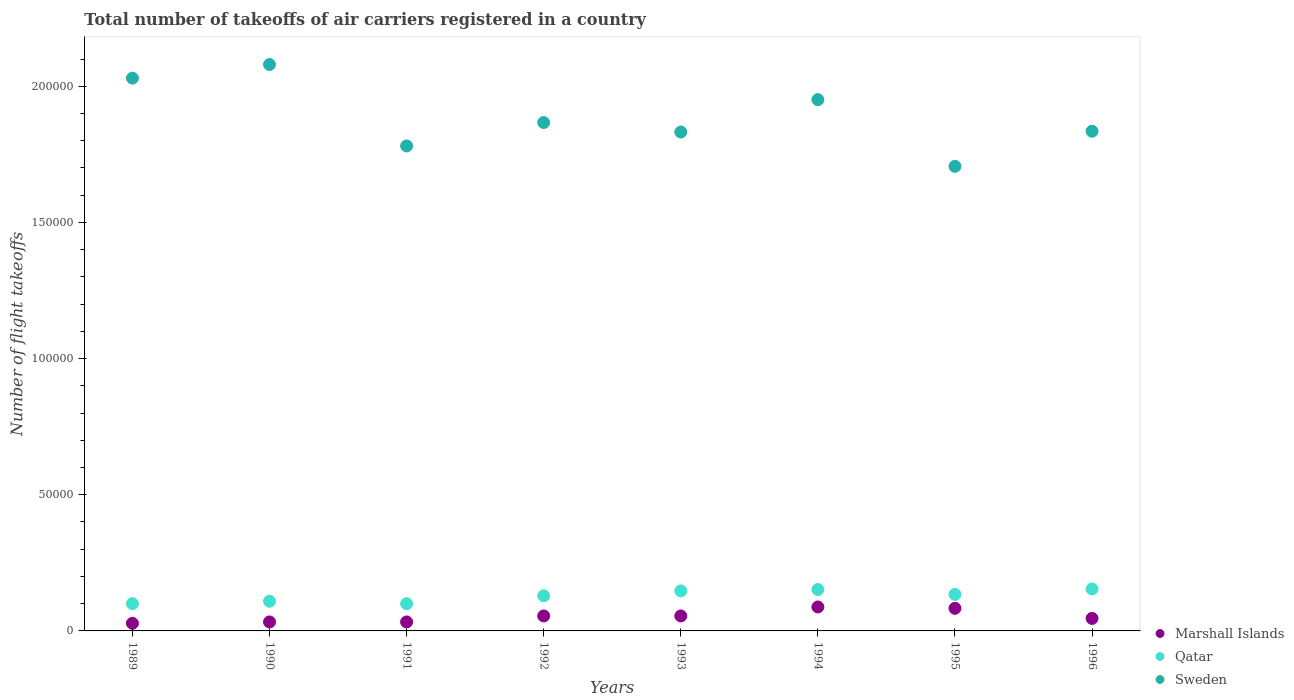Is the number of dotlines equal to the number of legend labels?
Your answer should be very brief. Yes. What is the total number of flight takeoffs in Qatar in 1996?
Offer a very short reply. 1.54e+04. Across all years, what is the maximum total number of flight takeoffs in Sweden?
Offer a terse response. 2.08e+05. Across all years, what is the minimum total number of flight takeoffs in Qatar?
Make the answer very short. 10000. In which year was the total number of flight takeoffs in Sweden minimum?
Offer a terse response. 1995. What is the total total number of flight takeoffs in Sweden in the graph?
Your answer should be very brief. 1.51e+06. What is the difference between the total number of flight takeoffs in Qatar in 1991 and that in 1995?
Make the answer very short. -3400. What is the difference between the total number of flight takeoffs in Sweden in 1992 and the total number of flight takeoffs in Marshall Islands in 1989?
Make the answer very short. 1.84e+05. What is the average total number of flight takeoffs in Sweden per year?
Give a very brief answer. 1.89e+05. In the year 1990, what is the difference between the total number of flight takeoffs in Qatar and total number of flight takeoffs in Sweden?
Keep it short and to the point. -1.97e+05. In how many years, is the total number of flight takeoffs in Qatar greater than 160000?
Give a very brief answer. 0. What is the ratio of the total number of flight takeoffs in Sweden in 1993 to that in 1995?
Keep it short and to the point. 1.07. Is the difference between the total number of flight takeoffs in Qatar in 1991 and 1995 greater than the difference between the total number of flight takeoffs in Sweden in 1991 and 1995?
Give a very brief answer. No. What is the difference between the highest and the second highest total number of flight takeoffs in Marshall Islands?
Make the answer very short. 500. What is the difference between the highest and the lowest total number of flight takeoffs in Marshall Islands?
Offer a very short reply. 6000. In how many years, is the total number of flight takeoffs in Sweden greater than the average total number of flight takeoffs in Sweden taken over all years?
Offer a terse response. 3. Is the total number of flight takeoffs in Sweden strictly greater than the total number of flight takeoffs in Qatar over the years?
Give a very brief answer. Yes. Is the total number of flight takeoffs in Sweden strictly less than the total number of flight takeoffs in Qatar over the years?
Offer a terse response. No. How many dotlines are there?
Make the answer very short. 3. What is the difference between two consecutive major ticks on the Y-axis?
Offer a terse response. 5.00e+04. Are the values on the major ticks of Y-axis written in scientific E-notation?
Your response must be concise. No. Does the graph contain any zero values?
Provide a succinct answer. No. Does the graph contain grids?
Ensure brevity in your answer.  No. What is the title of the graph?
Your answer should be compact. Total number of takeoffs of air carriers registered in a country. Does "Maldives" appear as one of the legend labels in the graph?
Keep it short and to the point. No. What is the label or title of the Y-axis?
Offer a terse response. Number of flight takeoffs. What is the Number of flight takeoffs of Marshall Islands in 1989?
Your response must be concise. 2800. What is the Number of flight takeoffs of Qatar in 1989?
Ensure brevity in your answer.  10000. What is the Number of flight takeoffs in Sweden in 1989?
Ensure brevity in your answer.  2.03e+05. What is the Number of flight takeoffs in Marshall Islands in 1990?
Offer a terse response. 3300. What is the Number of flight takeoffs in Qatar in 1990?
Your answer should be compact. 1.09e+04. What is the Number of flight takeoffs of Sweden in 1990?
Provide a short and direct response. 2.08e+05. What is the Number of flight takeoffs of Marshall Islands in 1991?
Offer a terse response. 3300. What is the Number of flight takeoffs of Qatar in 1991?
Your response must be concise. 10000. What is the Number of flight takeoffs of Sweden in 1991?
Give a very brief answer. 1.78e+05. What is the Number of flight takeoffs of Marshall Islands in 1992?
Provide a short and direct response. 5500. What is the Number of flight takeoffs of Qatar in 1992?
Your answer should be compact. 1.29e+04. What is the Number of flight takeoffs in Sweden in 1992?
Offer a very short reply. 1.87e+05. What is the Number of flight takeoffs of Marshall Islands in 1993?
Offer a very short reply. 5500. What is the Number of flight takeoffs in Qatar in 1993?
Provide a succinct answer. 1.47e+04. What is the Number of flight takeoffs of Sweden in 1993?
Offer a terse response. 1.83e+05. What is the Number of flight takeoffs in Marshall Islands in 1994?
Your response must be concise. 8800. What is the Number of flight takeoffs of Qatar in 1994?
Your response must be concise. 1.52e+04. What is the Number of flight takeoffs of Sweden in 1994?
Give a very brief answer. 1.95e+05. What is the Number of flight takeoffs of Marshall Islands in 1995?
Offer a very short reply. 8300. What is the Number of flight takeoffs of Qatar in 1995?
Offer a very short reply. 1.34e+04. What is the Number of flight takeoffs in Sweden in 1995?
Provide a succinct answer. 1.71e+05. What is the Number of flight takeoffs in Marshall Islands in 1996?
Ensure brevity in your answer.  4600. What is the Number of flight takeoffs of Qatar in 1996?
Provide a succinct answer. 1.54e+04. What is the Number of flight takeoffs of Sweden in 1996?
Give a very brief answer. 1.84e+05. Across all years, what is the maximum Number of flight takeoffs in Marshall Islands?
Ensure brevity in your answer.  8800. Across all years, what is the maximum Number of flight takeoffs in Qatar?
Keep it short and to the point. 1.54e+04. Across all years, what is the maximum Number of flight takeoffs in Sweden?
Keep it short and to the point. 2.08e+05. Across all years, what is the minimum Number of flight takeoffs in Marshall Islands?
Make the answer very short. 2800. Across all years, what is the minimum Number of flight takeoffs of Qatar?
Ensure brevity in your answer.  10000. Across all years, what is the minimum Number of flight takeoffs in Sweden?
Your response must be concise. 1.71e+05. What is the total Number of flight takeoffs of Marshall Islands in the graph?
Make the answer very short. 4.21e+04. What is the total Number of flight takeoffs of Qatar in the graph?
Your response must be concise. 1.02e+05. What is the total Number of flight takeoffs of Sweden in the graph?
Provide a short and direct response. 1.51e+06. What is the difference between the Number of flight takeoffs of Marshall Islands in 1989 and that in 1990?
Make the answer very short. -500. What is the difference between the Number of flight takeoffs of Qatar in 1989 and that in 1990?
Your answer should be compact. -900. What is the difference between the Number of flight takeoffs of Sweden in 1989 and that in 1990?
Keep it short and to the point. -5000. What is the difference between the Number of flight takeoffs in Marshall Islands in 1989 and that in 1991?
Provide a short and direct response. -500. What is the difference between the Number of flight takeoffs of Sweden in 1989 and that in 1991?
Your answer should be very brief. 2.49e+04. What is the difference between the Number of flight takeoffs in Marshall Islands in 1989 and that in 1992?
Provide a short and direct response. -2700. What is the difference between the Number of flight takeoffs of Qatar in 1989 and that in 1992?
Your answer should be compact. -2900. What is the difference between the Number of flight takeoffs in Sweden in 1989 and that in 1992?
Your answer should be very brief. 1.63e+04. What is the difference between the Number of flight takeoffs of Marshall Islands in 1989 and that in 1993?
Your answer should be very brief. -2700. What is the difference between the Number of flight takeoffs in Qatar in 1989 and that in 1993?
Your answer should be very brief. -4700. What is the difference between the Number of flight takeoffs in Sweden in 1989 and that in 1993?
Give a very brief answer. 1.98e+04. What is the difference between the Number of flight takeoffs in Marshall Islands in 1989 and that in 1994?
Give a very brief answer. -6000. What is the difference between the Number of flight takeoffs of Qatar in 1989 and that in 1994?
Make the answer very short. -5200. What is the difference between the Number of flight takeoffs in Sweden in 1989 and that in 1994?
Give a very brief answer. 7900. What is the difference between the Number of flight takeoffs of Marshall Islands in 1989 and that in 1995?
Provide a succinct answer. -5500. What is the difference between the Number of flight takeoffs of Qatar in 1989 and that in 1995?
Your response must be concise. -3400. What is the difference between the Number of flight takeoffs in Sweden in 1989 and that in 1995?
Provide a short and direct response. 3.24e+04. What is the difference between the Number of flight takeoffs in Marshall Islands in 1989 and that in 1996?
Your answer should be very brief. -1800. What is the difference between the Number of flight takeoffs in Qatar in 1989 and that in 1996?
Provide a succinct answer. -5400. What is the difference between the Number of flight takeoffs in Sweden in 1989 and that in 1996?
Ensure brevity in your answer.  1.95e+04. What is the difference between the Number of flight takeoffs of Marshall Islands in 1990 and that in 1991?
Your response must be concise. 0. What is the difference between the Number of flight takeoffs in Qatar in 1990 and that in 1991?
Keep it short and to the point. 900. What is the difference between the Number of flight takeoffs in Sweden in 1990 and that in 1991?
Keep it short and to the point. 2.99e+04. What is the difference between the Number of flight takeoffs in Marshall Islands in 1990 and that in 1992?
Provide a succinct answer. -2200. What is the difference between the Number of flight takeoffs in Qatar in 1990 and that in 1992?
Offer a terse response. -2000. What is the difference between the Number of flight takeoffs of Sweden in 1990 and that in 1992?
Make the answer very short. 2.13e+04. What is the difference between the Number of flight takeoffs of Marshall Islands in 1990 and that in 1993?
Provide a short and direct response. -2200. What is the difference between the Number of flight takeoffs of Qatar in 1990 and that in 1993?
Provide a short and direct response. -3800. What is the difference between the Number of flight takeoffs in Sweden in 1990 and that in 1993?
Ensure brevity in your answer.  2.48e+04. What is the difference between the Number of flight takeoffs in Marshall Islands in 1990 and that in 1994?
Your answer should be very brief. -5500. What is the difference between the Number of flight takeoffs in Qatar in 1990 and that in 1994?
Provide a short and direct response. -4300. What is the difference between the Number of flight takeoffs in Sweden in 1990 and that in 1994?
Offer a very short reply. 1.29e+04. What is the difference between the Number of flight takeoffs of Marshall Islands in 1990 and that in 1995?
Your answer should be compact. -5000. What is the difference between the Number of flight takeoffs of Qatar in 1990 and that in 1995?
Give a very brief answer. -2500. What is the difference between the Number of flight takeoffs of Sweden in 1990 and that in 1995?
Your answer should be very brief. 3.74e+04. What is the difference between the Number of flight takeoffs of Marshall Islands in 1990 and that in 1996?
Your response must be concise. -1300. What is the difference between the Number of flight takeoffs of Qatar in 1990 and that in 1996?
Offer a very short reply. -4500. What is the difference between the Number of flight takeoffs of Sweden in 1990 and that in 1996?
Make the answer very short. 2.45e+04. What is the difference between the Number of flight takeoffs of Marshall Islands in 1991 and that in 1992?
Keep it short and to the point. -2200. What is the difference between the Number of flight takeoffs of Qatar in 1991 and that in 1992?
Provide a succinct answer. -2900. What is the difference between the Number of flight takeoffs in Sweden in 1991 and that in 1992?
Ensure brevity in your answer.  -8600. What is the difference between the Number of flight takeoffs in Marshall Islands in 1991 and that in 1993?
Give a very brief answer. -2200. What is the difference between the Number of flight takeoffs in Qatar in 1991 and that in 1993?
Offer a terse response. -4700. What is the difference between the Number of flight takeoffs of Sweden in 1991 and that in 1993?
Ensure brevity in your answer.  -5100. What is the difference between the Number of flight takeoffs in Marshall Islands in 1991 and that in 1994?
Keep it short and to the point. -5500. What is the difference between the Number of flight takeoffs of Qatar in 1991 and that in 1994?
Keep it short and to the point. -5200. What is the difference between the Number of flight takeoffs of Sweden in 1991 and that in 1994?
Your response must be concise. -1.70e+04. What is the difference between the Number of flight takeoffs in Marshall Islands in 1991 and that in 1995?
Offer a terse response. -5000. What is the difference between the Number of flight takeoffs in Qatar in 1991 and that in 1995?
Keep it short and to the point. -3400. What is the difference between the Number of flight takeoffs in Sweden in 1991 and that in 1995?
Provide a short and direct response. 7500. What is the difference between the Number of flight takeoffs of Marshall Islands in 1991 and that in 1996?
Make the answer very short. -1300. What is the difference between the Number of flight takeoffs of Qatar in 1991 and that in 1996?
Provide a short and direct response. -5400. What is the difference between the Number of flight takeoffs of Sweden in 1991 and that in 1996?
Ensure brevity in your answer.  -5400. What is the difference between the Number of flight takeoffs of Qatar in 1992 and that in 1993?
Keep it short and to the point. -1800. What is the difference between the Number of flight takeoffs of Sweden in 1992 and that in 1993?
Provide a short and direct response. 3500. What is the difference between the Number of flight takeoffs in Marshall Islands in 1992 and that in 1994?
Provide a succinct answer. -3300. What is the difference between the Number of flight takeoffs in Qatar in 1992 and that in 1994?
Offer a terse response. -2300. What is the difference between the Number of flight takeoffs of Sweden in 1992 and that in 1994?
Keep it short and to the point. -8400. What is the difference between the Number of flight takeoffs in Marshall Islands in 1992 and that in 1995?
Your answer should be compact. -2800. What is the difference between the Number of flight takeoffs in Qatar in 1992 and that in 1995?
Make the answer very short. -500. What is the difference between the Number of flight takeoffs of Sweden in 1992 and that in 1995?
Your answer should be very brief. 1.61e+04. What is the difference between the Number of flight takeoffs in Marshall Islands in 1992 and that in 1996?
Offer a terse response. 900. What is the difference between the Number of flight takeoffs in Qatar in 1992 and that in 1996?
Provide a succinct answer. -2500. What is the difference between the Number of flight takeoffs of Sweden in 1992 and that in 1996?
Your answer should be compact. 3200. What is the difference between the Number of flight takeoffs of Marshall Islands in 1993 and that in 1994?
Keep it short and to the point. -3300. What is the difference between the Number of flight takeoffs in Qatar in 1993 and that in 1994?
Provide a succinct answer. -500. What is the difference between the Number of flight takeoffs of Sweden in 1993 and that in 1994?
Make the answer very short. -1.19e+04. What is the difference between the Number of flight takeoffs of Marshall Islands in 1993 and that in 1995?
Offer a terse response. -2800. What is the difference between the Number of flight takeoffs of Qatar in 1993 and that in 1995?
Your answer should be compact. 1300. What is the difference between the Number of flight takeoffs of Sweden in 1993 and that in 1995?
Give a very brief answer. 1.26e+04. What is the difference between the Number of flight takeoffs of Marshall Islands in 1993 and that in 1996?
Your answer should be compact. 900. What is the difference between the Number of flight takeoffs in Qatar in 1993 and that in 1996?
Your answer should be compact. -700. What is the difference between the Number of flight takeoffs in Sweden in 1993 and that in 1996?
Your response must be concise. -300. What is the difference between the Number of flight takeoffs in Marshall Islands in 1994 and that in 1995?
Your answer should be compact. 500. What is the difference between the Number of flight takeoffs of Qatar in 1994 and that in 1995?
Give a very brief answer. 1800. What is the difference between the Number of flight takeoffs in Sweden in 1994 and that in 1995?
Your answer should be very brief. 2.45e+04. What is the difference between the Number of flight takeoffs in Marshall Islands in 1994 and that in 1996?
Make the answer very short. 4200. What is the difference between the Number of flight takeoffs of Qatar in 1994 and that in 1996?
Provide a succinct answer. -200. What is the difference between the Number of flight takeoffs in Sweden in 1994 and that in 1996?
Provide a short and direct response. 1.16e+04. What is the difference between the Number of flight takeoffs of Marshall Islands in 1995 and that in 1996?
Offer a terse response. 3700. What is the difference between the Number of flight takeoffs in Qatar in 1995 and that in 1996?
Offer a terse response. -2000. What is the difference between the Number of flight takeoffs of Sweden in 1995 and that in 1996?
Your response must be concise. -1.29e+04. What is the difference between the Number of flight takeoffs in Marshall Islands in 1989 and the Number of flight takeoffs in Qatar in 1990?
Give a very brief answer. -8100. What is the difference between the Number of flight takeoffs of Marshall Islands in 1989 and the Number of flight takeoffs of Sweden in 1990?
Keep it short and to the point. -2.05e+05. What is the difference between the Number of flight takeoffs in Qatar in 1989 and the Number of flight takeoffs in Sweden in 1990?
Provide a short and direct response. -1.98e+05. What is the difference between the Number of flight takeoffs in Marshall Islands in 1989 and the Number of flight takeoffs in Qatar in 1991?
Ensure brevity in your answer.  -7200. What is the difference between the Number of flight takeoffs in Marshall Islands in 1989 and the Number of flight takeoffs in Sweden in 1991?
Ensure brevity in your answer.  -1.75e+05. What is the difference between the Number of flight takeoffs of Qatar in 1989 and the Number of flight takeoffs of Sweden in 1991?
Provide a succinct answer. -1.68e+05. What is the difference between the Number of flight takeoffs of Marshall Islands in 1989 and the Number of flight takeoffs of Qatar in 1992?
Your response must be concise. -1.01e+04. What is the difference between the Number of flight takeoffs in Marshall Islands in 1989 and the Number of flight takeoffs in Sweden in 1992?
Offer a terse response. -1.84e+05. What is the difference between the Number of flight takeoffs in Qatar in 1989 and the Number of flight takeoffs in Sweden in 1992?
Your answer should be very brief. -1.77e+05. What is the difference between the Number of flight takeoffs in Marshall Islands in 1989 and the Number of flight takeoffs in Qatar in 1993?
Provide a succinct answer. -1.19e+04. What is the difference between the Number of flight takeoffs in Marshall Islands in 1989 and the Number of flight takeoffs in Sweden in 1993?
Provide a short and direct response. -1.80e+05. What is the difference between the Number of flight takeoffs of Qatar in 1989 and the Number of flight takeoffs of Sweden in 1993?
Your response must be concise. -1.73e+05. What is the difference between the Number of flight takeoffs of Marshall Islands in 1989 and the Number of flight takeoffs of Qatar in 1994?
Your answer should be compact. -1.24e+04. What is the difference between the Number of flight takeoffs of Marshall Islands in 1989 and the Number of flight takeoffs of Sweden in 1994?
Offer a terse response. -1.92e+05. What is the difference between the Number of flight takeoffs in Qatar in 1989 and the Number of flight takeoffs in Sweden in 1994?
Offer a terse response. -1.85e+05. What is the difference between the Number of flight takeoffs in Marshall Islands in 1989 and the Number of flight takeoffs in Qatar in 1995?
Provide a short and direct response. -1.06e+04. What is the difference between the Number of flight takeoffs in Marshall Islands in 1989 and the Number of flight takeoffs in Sweden in 1995?
Ensure brevity in your answer.  -1.68e+05. What is the difference between the Number of flight takeoffs in Qatar in 1989 and the Number of flight takeoffs in Sweden in 1995?
Offer a very short reply. -1.61e+05. What is the difference between the Number of flight takeoffs of Marshall Islands in 1989 and the Number of flight takeoffs of Qatar in 1996?
Make the answer very short. -1.26e+04. What is the difference between the Number of flight takeoffs of Marshall Islands in 1989 and the Number of flight takeoffs of Sweden in 1996?
Your answer should be very brief. -1.81e+05. What is the difference between the Number of flight takeoffs in Qatar in 1989 and the Number of flight takeoffs in Sweden in 1996?
Provide a short and direct response. -1.74e+05. What is the difference between the Number of flight takeoffs in Marshall Islands in 1990 and the Number of flight takeoffs in Qatar in 1991?
Provide a succinct answer. -6700. What is the difference between the Number of flight takeoffs in Marshall Islands in 1990 and the Number of flight takeoffs in Sweden in 1991?
Your answer should be very brief. -1.75e+05. What is the difference between the Number of flight takeoffs of Qatar in 1990 and the Number of flight takeoffs of Sweden in 1991?
Offer a terse response. -1.67e+05. What is the difference between the Number of flight takeoffs of Marshall Islands in 1990 and the Number of flight takeoffs of Qatar in 1992?
Keep it short and to the point. -9600. What is the difference between the Number of flight takeoffs of Marshall Islands in 1990 and the Number of flight takeoffs of Sweden in 1992?
Offer a very short reply. -1.83e+05. What is the difference between the Number of flight takeoffs in Qatar in 1990 and the Number of flight takeoffs in Sweden in 1992?
Offer a very short reply. -1.76e+05. What is the difference between the Number of flight takeoffs of Marshall Islands in 1990 and the Number of flight takeoffs of Qatar in 1993?
Provide a short and direct response. -1.14e+04. What is the difference between the Number of flight takeoffs of Marshall Islands in 1990 and the Number of flight takeoffs of Sweden in 1993?
Make the answer very short. -1.80e+05. What is the difference between the Number of flight takeoffs of Qatar in 1990 and the Number of flight takeoffs of Sweden in 1993?
Provide a succinct answer. -1.72e+05. What is the difference between the Number of flight takeoffs of Marshall Islands in 1990 and the Number of flight takeoffs of Qatar in 1994?
Your answer should be compact. -1.19e+04. What is the difference between the Number of flight takeoffs in Marshall Islands in 1990 and the Number of flight takeoffs in Sweden in 1994?
Provide a succinct answer. -1.92e+05. What is the difference between the Number of flight takeoffs of Qatar in 1990 and the Number of flight takeoffs of Sweden in 1994?
Give a very brief answer. -1.84e+05. What is the difference between the Number of flight takeoffs of Marshall Islands in 1990 and the Number of flight takeoffs of Qatar in 1995?
Your answer should be compact. -1.01e+04. What is the difference between the Number of flight takeoffs in Marshall Islands in 1990 and the Number of flight takeoffs in Sweden in 1995?
Ensure brevity in your answer.  -1.67e+05. What is the difference between the Number of flight takeoffs in Qatar in 1990 and the Number of flight takeoffs in Sweden in 1995?
Keep it short and to the point. -1.60e+05. What is the difference between the Number of flight takeoffs in Marshall Islands in 1990 and the Number of flight takeoffs in Qatar in 1996?
Provide a succinct answer. -1.21e+04. What is the difference between the Number of flight takeoffs in Marshall Islands in 1990 and the Number of flight takeoffs in Sweden in 1996?
Offer a terse response. -1.80e+05. What is the difference between the Number of flight takeoffs of Qatar in 1990 and the Number of flight takeoffs of Sweden in 1996?
Give a very brief answer. -1.73e+05. What is the difference between the Number of flight takeoffs in Marshall Islands in 1991 and the Number of flight takeoffs in Qatar in 1992?
Provide a short and direct response. -9600. What is the difference between the Number of flight takeoffs of Marshall Islands in 1991 and the Number of flight takeoffs of Sweden in 1992?
Offer a terse response. -1.83e+05. What is the difference between the Number of flight takeoffs of Qatar in 1991 and the Number of flight takeoffs of Sweden in 1992?
Your response must be concise. -1.77e+05. What is the difference between the Number of flight takeoffs in Marshall Islands in 1991 and the Number of flight takeoffs in Qatar in 1993?
Your response must be concise. -1.14e+04. What is the difference between the Number of flight takeoffs of Marshall Islands in 1991 and the Number of flight takeoffs of Sweden in 1993?
Give a very brief answer. -1.80e+05. What is the difference between the Number of flight takeoffs in Qatar in 1991 and the Number of flight takeoffs in Sweden in 1993?
Keep it short and to the point. -1.73e+05. What is the difference between the Number of flight takeoffs of Marshall Islands in 1991 and the Number of flight takeoffs of Qatar in 1994?
Give a very brief answer. -1.19e+04. What is the difference between the Number of flight takeoffs of Marshall Islands in 1991 and the Number of flight takeoffs of Sweden in 1994?
Keep it short and to the point. -1.92e+05. What is the difference between the Number of flight takeoffs in Qatar in 1991 and the Number of flight takeoffs in Sweden in 1994?
Offer a very short reply. -1.85e+05. What is the difference between the Number of flight takeoffs in Marshall Islands in 1991 and the Number of flight takeoffs in Qatar in 1995?
Your answer should be very brief. -1.01e+04. What is the difference between the Number of flight takeoffs in Marshall Islands in 1991 and the Number of flight takeoffs in Sweden in 1995?
Give a very brief answer. -1.67e+05. What is the difference between the Number of flight takeoffs in Qatar in 1991 and the Number of flight takeoffs in Sweden in 1995?
Offer a very short reply. -1.61e+05. What is the difference between the Number of flight takeoffs in Marshall Islands in 1991 and the Number of flight takeoffs in Qatar in 1996?
Make the answer very short. -1.21e+04. What is the difference between the Number of flight takeoffs in Marshall Islands in 1991 and the Number of flight takeoffs in Sweden in 1996?
Offer a very short reply. -1.80e+05. What is the difference between the Number of flight takeoffs of Qatar in 1991 and the Number of flight takeoffs of Sweden in 1996?
Keep it short and to the point. -1.74e+05. What is the difference between the Number of flight takeoffs in Marshall Islands in 1992 and the Number of flight takeoffs in Qatar in 1993?
Ensure brevity in your answer.  -9200. What is the difference between the Number of flight takeoffs in Marshall Islands in 1992 and the Number of flight takeoffs in Sweden in 1993?
Provide a short and direct response. -1.78e+05. What is the difference between the Number of flight takeoffs in Qatar in 1992 and the Number of flight takeoffs in Sweden in 1993?
Give a very brief answer. -1.70e+05. What is the difference between the Number of flight takeoffs of Marshall Islands in 1992 and the Number of flight takeoffs of Qatar in 1994?
Provide a succinct answer. -9700. What is the difference between the Number of flight takeoffs of Marshall Islands in 1992 and the Number of flight takeoffs of Sweden in 1994?
Your response must be concise. -1.90e+05. What is the difference between the Number of flight takeoffs of Qatar in 1992 and the Number of flight takeoffs of Sweden in 1994?
Your answer should be very brief. -1.82e+05. What is the difference between the Number of flight takeoffs of Marshall Islands in 1992 and the Number of flight takeoffs of Qatar in 1995?
Ensure brevity in your answer.  -7900. What is the difference between the Number of flight takeoffs of Marshall Islands in 1992 and the Number of flight takeoffs of Sweden in 1995?
Offer a terse response. -1.65e+05. What is the difference between the Number of flight takeoffs of Qatar in 1992 and the Number of flight takeoffs of Sweden in 1995?
Make the answer very short. -1.58e+05. What is the difference between the Number of flight takeoffs in Marshall Islands in 1992 and the Number of flight takeoffs in Qatar in 1996?
Keep it short and to the point. -9900. What is the difference between the Number of flight takeoffs of Marshall Islands in 1992 and the Number of flight takeoffs of Sweden in 1996?
Keep it short and to the point. -1.78e+05. What is the difference between the Number of flight takeoffs in Qatar in 1992 and the Number of flight takeoffs in Sweden in 1996?
Give a very brief answer. -1.71e+05. What is the difference between the Number of flight takeoffs in Marshall Islands in 1993 and the Number of flight takeoffs in Qatar in 1994?
Give a very brief answer. -9700. What is the difference between the Number of flight takeoffs in Marshall Islands in 1993 and the Number of flight takeoffs in Sweden in 1994?
Your answer should be compact. -1.90e+05. What is the difference between the Number of flight takeoffs in Qatar in 1993 and the Number of flight takeoffs in Sweden in 1994?
Make the answer very short. -1.80e+05. What is the difference between the Number of flight takeoffs of Marshall Islands in 1993 and the Number of flight takeoffs of Qatar in 1995?
Provide a succinct answer. -7900. What is the difference between the Number of flight takeoffs in Marshall Islands in 1993 and the Number of flight takeoffs in Sweden in 1995?
Make the answer very short. -1.65e+05. What is the difference between the Number of flight takeoffs of Qatar in 1993 and the Number of flight takeoffs of Sweden in 1995?
Provide a short and direct response. -1.56e+05. What is the difference between the Number of flight takeoffs in Marshall Islands in 1993 and the Number of flight takeoffs in Qatar in 1996?
Provide a succinct answer. -9900. What is the difference between the Number of flight takeoffs of Marshall Islands in 1993 and the Number of flight takeoffs of Sweden in 1996?
Provide a short and direct response. -1.78e+05. What is the difference between the Number of flight takeoffs of Qatar in 1993 and the Number of flight takeoffs of Sweden in 1996?
Provide a short and direct response. -1.69e+05. What is the difference between the Number of flight takeoffs in Marshall Islands in 1994 and the Number of flight takeoffs in Qatar in 1995?
Your answer should be compact. -4600. What is the difference between the Number of flight takeoffs of Marshall Islands in 1994 and the Number of flight takeoffs of Sweden in 1995?
Provide a succinct answer. -1.62e+05. What is the difference between the Number of flight takeoffs in Qatar in 1994 and the Number of flight takeoffs in Sweden in 1995?
Your answer should be compact. -1.55e+05. What is the difference between the Number of flight takeoffs in Marshall Islands in 1994 and the Number of flight takeoffs in Qatar in 1996?
Ensure brevity in your answer.  -6600. What is the difference between the Number of flight takeoffs of Marshall Islands in 1994 and the Number of flight takeoffs of Sweden in 1996?
Offer a terse response. -1.75e+05. What is the difference between the Number of flight takeoffs in Qatar in 1994 and the Number of flight takeoffs in Sweden in 1996?
Your answer should be compact. -1.68e+05. What is the difference between the Number of flight takeoffs of Marshall Islands in 1995 and the Number of flight takeoffs of Qatar in 1996?
Ensure brevity in your answer.  -7100. What is the difference between the Number of flight takeoffs of Marshall Islands in 1995 and the Number of flight takeoffs of Sweden in 1996?
Offer a very short reply. -1.75e+05. What is the difference between the Number of flight takeoffs of Qatar in 1995 and the Number of flight takeoffs of Sweden in 1996?
Provide a succinct answer. -1.70e+05. What is the average Number of flight takeoffs of Marshall Islands per year?
Make the answer very short. 5262.5. What is the average Number of flight takeoffs in Qatar per year?
Give a very brief answer. 1.28e+04. What is the average Number of flight takeoffs of Sweden per year?
Provide a succinct answer. 1.89e+05. In the year 1989, what is the difference between the Number of flight takeoffs in Marshall Islands and Number of flight takeoffs in Qatar?
Offer a very short reply. -7200. In the year 1989, what is the difference between the Number of flight takeoffs of Marshall Islands and Number of flight takeoffs of Sweden?
Your answer should be compact. -2.00e+05. In the year 1989, what is the difference between the Number of flight takeoffs in Qatar and Number of flight takeoffs in Sweden?
Your answer should be very brief. -1.93e+05. In the year 1990, what is the difference between the Number of flight takeoffs of Marshall Islands and Number of flight takeoffs of Qatar?
Provide a short and direct response. -7600. In the year 1990, what is the difference between the Number of flight takeoffs of Marshall Islands and Number of flight takeoffs of Sweden?
Give a very brief answer. -2.05e+05. In the year 1990, what is the difference between the Number of flight takeoffs of Qatar and Number of flight takeoffs of Sweden?
Give a very brief answer. -1.97e+05. In the year 1991, what is the difference between the Number of flight takeoffs of Marshall Islands and Number of flight takeoffs of Qatar?
Your response must be concise. -6700. In the year 1991, what is the difference between the Number of flight takeoffs in Marshall Islands and Number of flight takeoffs in Sweden?
Ensure brevity in your answer.  -1.75e+05. In the year 1991, what is the difference between the Number of flight takeoffs of Qatar and Number of flight takeoffs of Sweden?
Provide a short and direct response. -1.68e+05. In the year 1992, what is the difference between the Number of flight takeoffs in Marshall Islands and Number of flight takeoffs in Qatar?
Offer a terse response. -7400. In the year 1992, what is the difference between the Number of flight takeoffs of Marshall Islands and Number of flight takeoffs of Sweden?
Offer a terse response. -1.81e+05. In the year 1992, what is the difference between the Number of flight takeoffs of Qatar and Number of flight takeoffs of Sweden?
Offer a very short reply. -1.74e+05. In the year 1993, what is the difference between the Number of flight takeoffs of Marshall Islands and Number of flight takeoffs of Qatar?
Offer a very short reply. -9200. In the year 1993, what is the difference between the Number of flight takeoffs of Marshall Islands and Number of flight takeoffs of Sweden?
Your answer should be very brief. -1.78e+05. In the year 1993, what is the difference between the Number of flight takeoffs in Qatar and Number of flight takeoffs in Sweden?
Your answer should be very brief. -1.68e+05. In the year 1994, what is the difference between the Number of flight takeoffs in Marshall Islands and Number of flight takeoffs in Qatar?
Make the answer very short. -6400. In the year 1994, what is the difference between the Number of flight takeoffs of Marshall Islands and Number of flight takeoffs of Sweden?
Provide a succinct answer. -1.86e+05. In the year 1994, what is the difference between the Number of flight takeoffs of Qatar and Number of flight takeoffs of Sweden?
Provide a short and direct response. -1.80e+05. In the year 1995, what is the difference between the Number of flight takeoffs of Marshall Islands and Number of flight takeoffs of Qatar?
Make the answer very short. -5100. In the year 1995, what is the difference between the Number of flight takeoffs in Marshall Islands and Number of flight takeoffs in Sweden?
Provide a succinct answer. -1.62e+05. In the year 1995, what is the difference between the Number of flight takeoffs in Qatar and Number of flight takeoffs in Sweden?
Offer a terse response. -1.57e+05. In the year 1996, what is the difference between the Number of flight takeoffs in Marshall Islands and Number of flight takeoffs in Qatar?
Ensure brevity in your answer.  -1.08e+04. In the year 1996, what is the difference between the Number of flight takeoffs of Marshall Islands and Number of flight takeoffs of Sweden?
Your response must be concise. -1.79e+05. In the year 1996, what is the difference between the Number of flight takeoffs in Qatar and Number of flight takeoffs in Sweden?
Your response must be concise. -1.68e+05. What is the ratio of the Number of flight takeoffs in Marshall Islands in 1989 to that in 1990?
Provide a succinct answer. 0.85. What is the ratio of the Number of flight takeoffs in Qatar in 1989 to that in 1990?
Offer a terse response. 0.92. What is the ratio of the Number of flight takeoffs in Marshall Islands in 1989 to that in 1991?
Provide a succinct answer. 0.85. What is the ratio of the Number of flight takeoffs in Qatar in 1989 to that in 1991?
Give a very brief answer. 1. What is the ratio of the Number of flight takeoffs of Sweden in 1989 to that in 1991?
Keep it short and to the point. 1.14. What is the ratio of the Number of flight takeoffs of Marshall Islands in 1989 to that in 1992?
Make the answer very short. 0.51. What is the ratio of the Number of flight takeoffs in Qatar in 1989 to that in 1992?
Your answer should be very brief. 0.78. What is the ratio of the Number of flight takeoffs of Sweden in 1989 to that in 1992?
Give a very brief answer. 1.09. What is the ratio of the Number of flight takeoffs of Marshall Islands in 1989 to that in 1993?
Your answer should be compact. 0.51. What is the ratio of the Number of flight takeoffs of Qatar in 1989 to that in 1993?
Make the answer very short. 0.68. What is the ratio of the Number of flight takeoffs of Sweden in 1989 to that in 1993?
Offer a terse response. 1.11. What is the ratio of the Number of flight takeoffs of Marshall Islands in 1989 to that in 1994?
Your answer should be very brief. 0.32. What is the ratio of the Number of flight takeoffs of Qatar in 1989 to that in 1994?
Offer a very short reply. 0.66. What is the ratio of the Number of flight takeoffs in Sweden in 1989 to that in 1994?
Keep it short and to the point. 1.04. What is the ratio of the Number of flight takeoffs of Marshall Islands in 1989 to that in 1995?
Make the answer very short. 0.34. What is the ratio of the Number of flight takeoffs in Qatar in 1989 to that in 1995?
Offer a very short reply. 0.75. What is the ratio of the Number of flight takeoffs of Sweden in 1989 to that in 1995?
Keep it short and to the point. 1.19. What is the ratio of the Number of flight takeoffs of Marshall Islands in 1989 to that in 1996?
Make the answer very short. 0.61. What is the ratio of the Number of flight takeoffs of Qatar in 1989 to that in 1996?
Give a very brief answer. 0.65. What is the ratio of the Number of flight takeoffs in Sweden in 1989 to that in 1996?
Provide a succinct answer. 1.11. What is the ratio of the Number of flight takeoffs of Qatar in 1990 to that in 1991?
Your response must be concise. 1.09. What is the ratio of the Number of flight takeoffs of Sweden in 1990 to that in 1991?
Your answer should be compact. 1.17. What is the ratio of the Number of flight takeoffs of Qatar in 1990 to that in 1992?
Make the answer very short. 0.84. What is the ratio of the Number of flight takeoffs of Sweden in 1990 to that in 1992?
Make the answer very short. 1.11. What is the ratio of the Number of flight takeoffs in Qatar in 1990 to that in 1993?
Give a very brief answer. 0.74. What is the ratio of the Number of flight takeoffs of Sweden in 1990 to that in 1993?
Ensure brevity in your answer.  1.14. What is the ratio of the Number of flight takeoffs of Marshall Islands in 1990 to that in 1994?
Make the answer very short. 0.38. What is the ratio of the Number of flight takeoffs in Qatar in 1990 to that in 1994?
Offer a very short reply. 0.72. What is the ratio of the Number of flight takeoffs of Sweden in 1990 to that in 1994?
Your answer should be very brief. 1.07. What is the ratio of the Number of flight takeoffs of Marshall Islands in 1990 to that in 1995?
Offer a terse response. 0.4. What is the ratio of the Number of flight takeoffs of Qatar in 1990 to that in 1995?
Make the answer very short. 0.81. What is the ratio of the Number of flight takeoffs of Sweden in 1990 to that in 1995?
Provide a succinct answer. 1.22. What is the ratio of the Number of flight takeoffs in Marshall Islands in 1990 to that in 1996?
Provide a succinct answer. 0.72. What is the ratio of the Number of flight takeoffs in Qatar in 1990 to that in 1996?
Your answer should be very brief. 0.71. What is the ratio of the Number of flight takeoffs of Sweden in 1990 to that in 1996?
Your answer should be compact. 1.13. What is the ratio of the Number of flight takeoffs in Marshall Islands in 1991 to that in 1992?
Keep it short and to the point. 0.6. What is the ratio of the Number of flight takeoffs in Qatar in 1991 to that in 1992?
Your answer should be very brief. 0.78. What is the ratio of the Number of flight takeoffs of Sweden in 1991 to that in 1992?
Provide a short and direct response. 0.95. What is the ratio of the Number of flight takeoffs of Marshall Islands in 1991 to that in 1993?
Make the answer very short. 0.6. What is the ratio of the Number of flight takeoffs of Qatar in 1991 to that in 1993?
Keep it short and to the point. 0.68. What is the ratio of the Number of flight takeoffs in Sweden in 1991 to that in 1993?
Make the answer very short. 0.97. What is the ratio of the Number of flight takeoffs of Marshall Islands in 1991 to that in 1994?
Make the answer very short. 0.38. What is the ratio of the Number of flight takeoffs of Qatar in 1991 to that in 1994?
Provide a succinct answer. 0.66. What is the ratio of the Number of flight takeoffs in Sweden in 1991 to that in 1994?
Give a very brief answer. 0.91. What is the ratio of the Number of flight takeoffs of Marshall Islands in 1991 to that in 1995?
Your response must be concise. 0.4. What is the ratio of the Number of flight takeoffs in Qatar in 1991 to that in 1995?
Your response must be concise. 0.75. What is the ratio of the Number of flight takeoffs in Sweden in 1991 to that in 1995?
Make the answer very short. 1.04. What is the ratio of the Number of flight takeoffs in Marshall Islands in 1991 to that in 1996?
Make the answer very short. 0.72. What is the ratio of the Number of flight takeoffs in Qatar in 1991 to that in 1996?
Your answer should be compact. 0.65. What is the ratio of the Number of flight takeoffs in Sweden in 1991 to that in 1996?
Give a very brief answer. 0.97. What is the ratio of the Number of flight takeoffs of Qatar in 1992 to that in 1993?
Keep it short and to the point. 0.88. What is the ratio of the Number of flight takeoffs of Sweden in 1992 to that in 1993?
Your answer should be very brief. 1.02. What is the ratio of the Number of flight takeoffs in Marshall Islands in 1992 to that in 1994?
Your response must be concise. 0.62. What is the ratio of the Number of flight takeoffs of Qatar in 1992 to that in 1994?
Your answer should be compact. 0.85. What is the ratio of the Number of flight takeoffs of Sweden in 1992 to that in 1994?
Provide a short and direct response. 0.96. What is the ratio of the Number of flight takeoffs in Marshall Islands in 1992 to that in 1995?
Ensure brevity in your answer.  0.66. What is the ratio of the Number of flight takeoffs in Qatar in 1992 to that in 1995?
Keep it short and to the point. 0.96. What is the ratio of the Number of flight takeoffs in Sweden in 1992 to that in 1995?
Provide a short and direct response. 1.09. What is the ratio of the Number of flight takeoffs in Marshall Islands in 1992 to that in 1996?
Give a very brief answer. 1.2. What is the ratio of the Number of flight takeoffs of Qatar in 1992 to that in 1996?
Make the answer very short. 0.84. What is the ratio of the Number of flight takeoffs of Sweden in 1992 to that in 1996?
Keep it short and to the point. 1.02. What is the ratio of the Number of flight takeoffs in Marshall Islands in 1993 to that in 1994?
Offer a very short reply. 0.62. What is the ratio of the Number of flight takeoffs of Qatar in 1993 to that in 1994?
Keep it short and to the point. 0.97. What is the ratio of the Number of flight takeoffs of Sweden in 1993 to that in 1994?
Your answer should be compact. 0.94. What is the ratio of the Number of flight takeoffs of Marshall Islands in 1993 to that in 1995?
Your answer should be very brief. 0.66. What is the ratio of the Number of flight takeoffs of Qatar in 1993 to that in 1995?
Your answer should be very brief. 1.1. What is the ratio of the Number of flight takeoffs of Sweden in 1993 to that in 1995?
Keep it short and to the point. 1.07. What is the ratio of the Number of flight takeoffs in Marshall Islands in 1993 to that in 1996?
Keep it short and to the point. 1.2. What is the ratio of the Number of flight takeoffs of Qatar in 1993 to that in 1996?
Make the answer very short. 0.95. What is the ratio of the Number of flight takeoffs of Marshall Islands in 1994 to that in 1995?
Ensure brevity in your answer.  1.06. What is the ratio of the Number of flight takeoffs in Qatar in 1994 to that in 1995?
Make the answer very short. 1.13. What is the ratio of the Number of flight takeoffs in Sweden in 1994 to that in 1995?
Keep it short and to the point. 1.14. What is the ratio of the Number of flight takeoffs of Marshall Islands in 1994 to that in 1996?
Offer a terse response. 1.91. What is the ratio of the Number of flight takeoffs of Qatar in 1994 to that in 1996?
Keep it short and to the point. 0.99. What is the ratio of the Number of flight takeoffs in Sweden in 1994 to that in 1996?
Your response must be concise. 1.06. What is the ratio of the Number of flight takeoffs in Marshall Islands in 1995 to that in 1996?
Offer a very short reply. 1.8. What is the ratio of the Number of flight takeoffs of Qatar in 1995 to that in 1996?
Offer a very short reply. 0.87. What is the ratio of the Number of flight takeoffs of Sweden in 1995 to that in 1996?
Give a very brief answer. 0.93. What is the difference between the highest and the second highest Number of flight takeoffs in Sweden?
Your response must be concise. 5000. What is the difference between the highest and the lowest Number of flight takeoffs in Marshall Islands?
Give a very brief answer. 6000. What is the difference between the highest and the lowest Number of flight takeoffs of Qatar?
Offer a terse response. 5400. What is the difference between the highest and the lowest Number of flight takeoffs of Sweden?
Make the answer very short. 3.74e+04. 